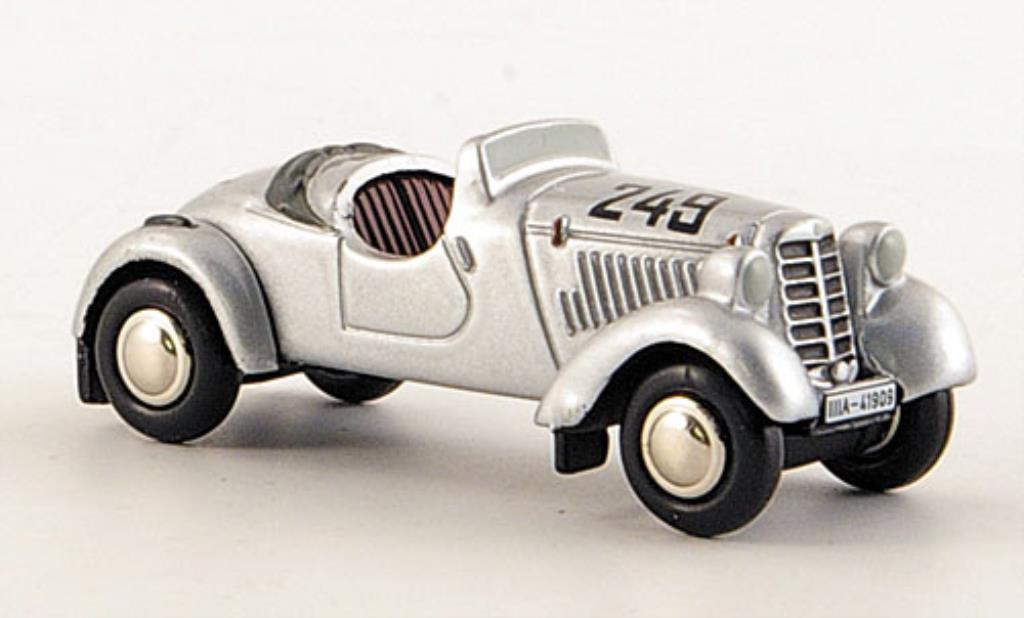Considering the details present on the model car, such as the race number "243" and the code "IA-1935" on the hood, what might the significance of these numbers be and how could they relate to the historical context or specific events the car may represent? Based on the image alone, the number '243' suggests that the car is modeled after a vehicle used in racing events, as numbers of this type are typically associated with race identification. The code 'IA-1935' on the hood likely indicates the year 1935, either referencing the manufacturing year of the original car or the year it took part in a significant race. Such a model replicates historic race cars from the mid-1930s, possibly drawing from a particular race or event from 1935. Although further details are needed to pinpoint the exact history, these numbers strongly point towards a racing heritage from that time period. 